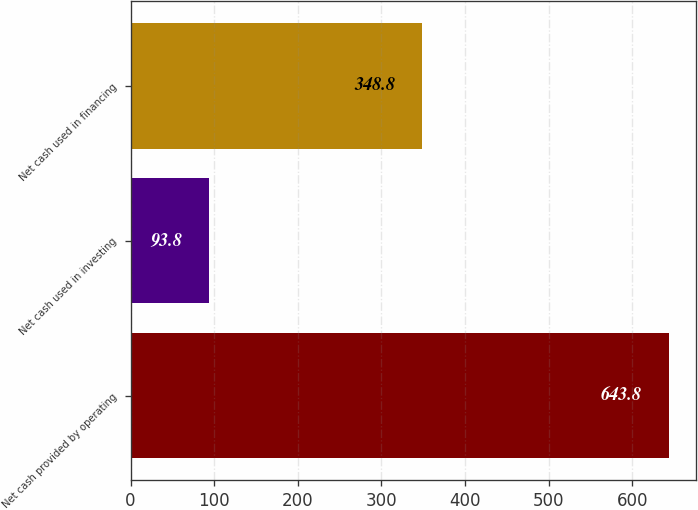<chart> <loc_0><loc_0><loc_500><loc_500><bar_chart><fcel>Net cash provided by operating<fcel>Net cash used in investing<fcel>Net cash used in financing<nl><fcel>643.8<fcel>93.8<fcel>348.8<nl></chart> 